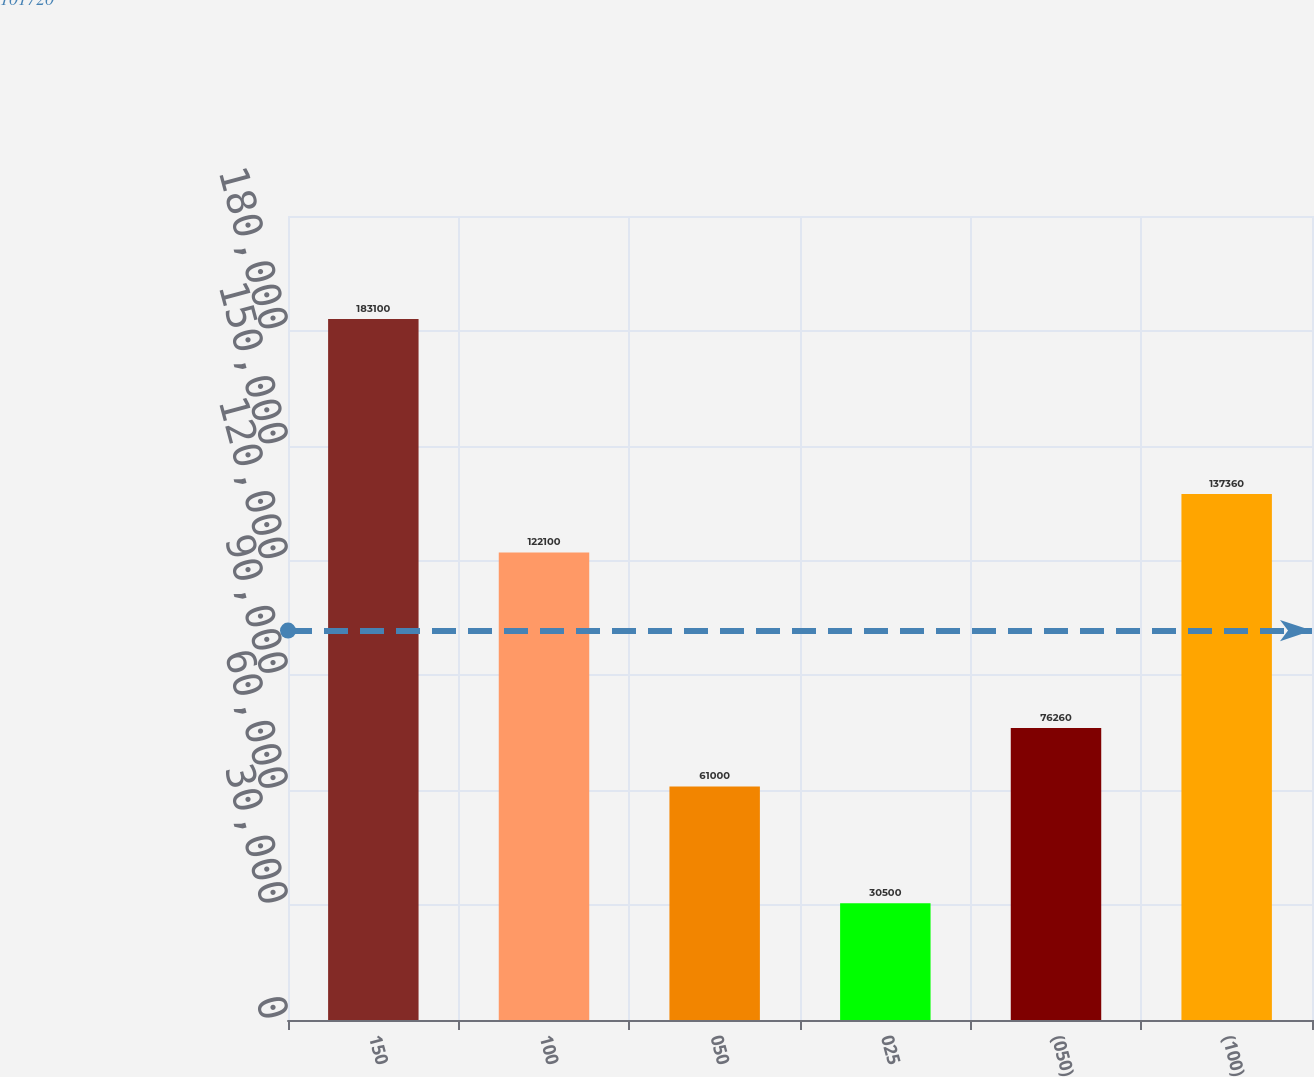Convert chart. <chart><loc_0><loc_0><loc_500><loc_500><bar_chart><fcel>150<fcel>100<fcel>050<fcel>025<fcel>(050)<fcel>(100)<nl><fcel>183100<fcel>122100<fcel>61000<fcel>30500<fcel>76260<fcel>137360<nl></chart> 